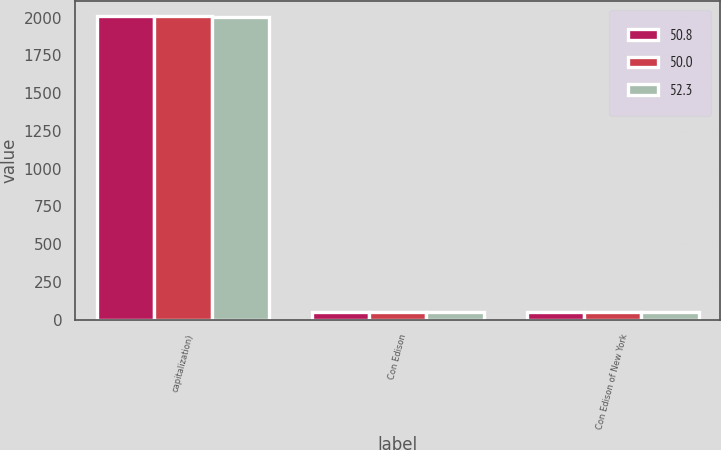Convert chart. <chart><loc_0><loc_0><loc_500><loc_500><stacked_bar_chart><ecel><fcel>capitalization)<fcel>Con Edison<fcel>Con Edison of New York<nl><fcel>50.8<fcel>2008<fcel>50.7<fcel>50.8<nl><fcel>50<fcel>2007<fcel>53.7<fcel>52.3<nl><fcel>52.3<fcel>2006<fcel>48.5<fcel>50<nl></chart> 